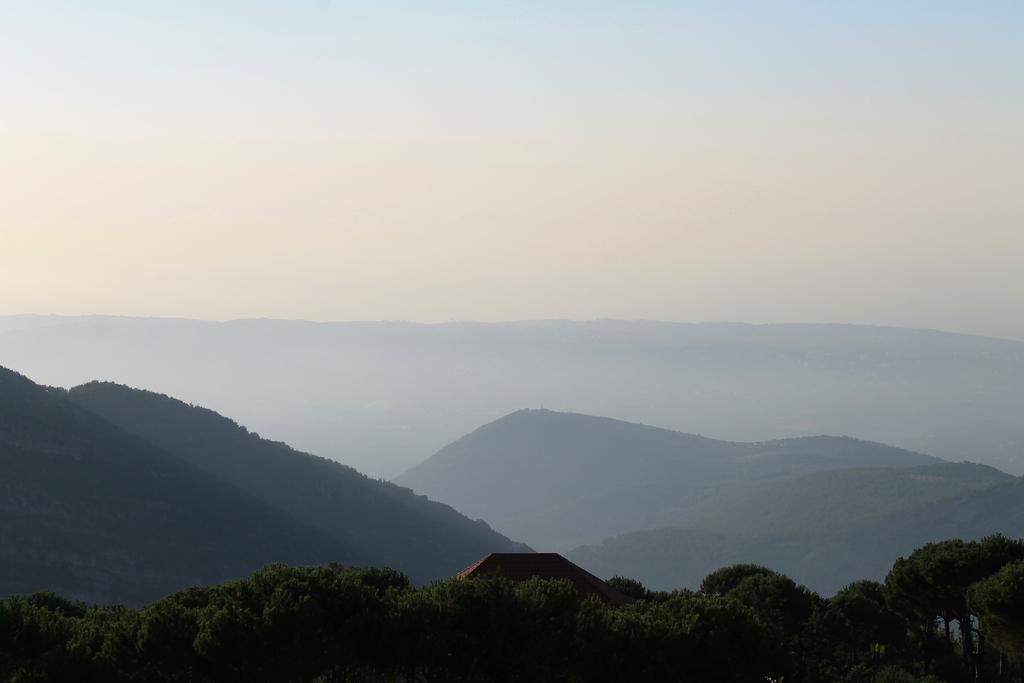Describe this image in one or two sentences. In this image I can see few trees which are green in color and few buildings. In the background I can see few mountains and the sky. 